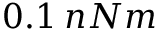Convert formula to latex. <formula><loc_0><loc_0><loc_500><loc_500>0 . 1 \, n N m</formula> 